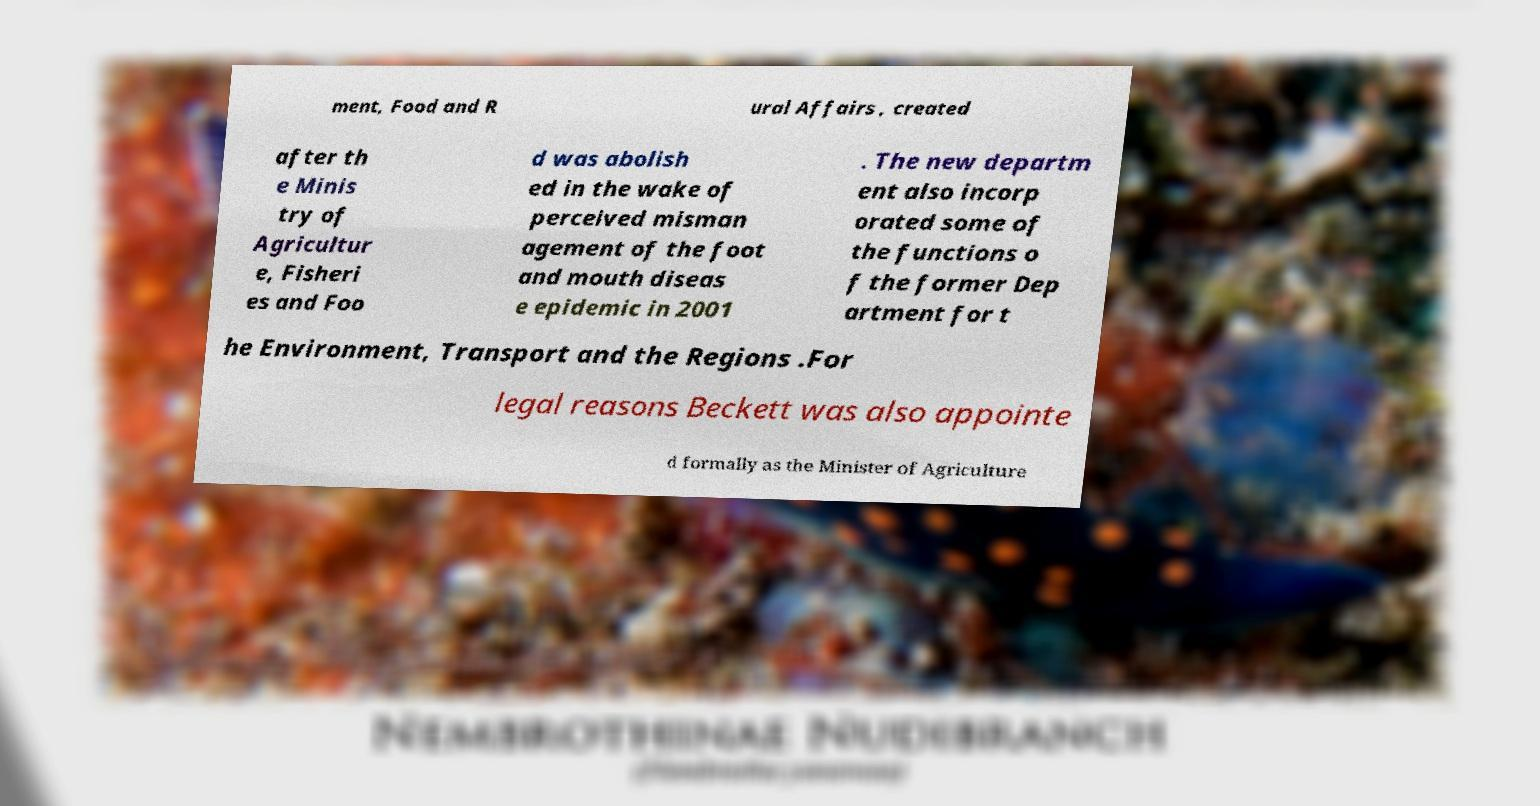For documentation purposes, I need the text within this image transcribed. Could you provide that? ment, Food and R ural Affairs , created after th e Minis try of Agricultur e, Fisheri es and Foo d was abolish ed in the wake of perceived misman agement of the foot and mouth diseas e epidemic in 2001 . The new departm ent also incorp orated some of the functions o f the former Dep artment for t he Environment, Transport and the Regions .For legal reasons Beckett was also appointe d formally as the Minister of Agriculture 